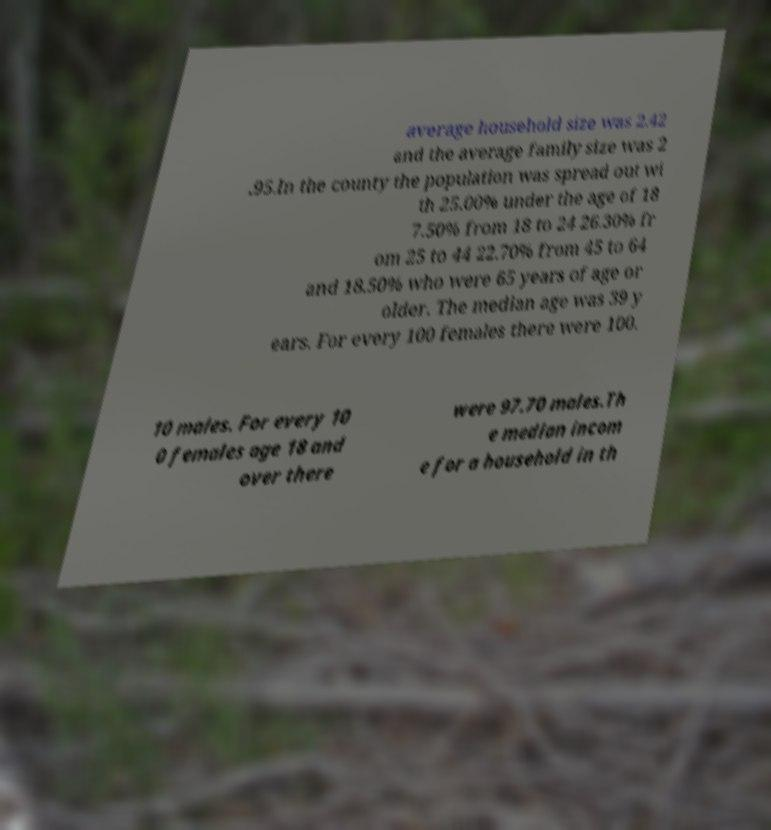Please read and relay the text visible in this image. What does it say? average household size was 2.42 and the average family size was 2 .95.In the county the population was spread out wi th 25.00% under the age of 18 7.50% from 18 to 24 26.30% fr om 25 to 44 22.70% from 45 to 64 and 18.50% who were 65 years of age or older. The median age was 39 y ears. For every 100 females there were 100. 10 males. For every 10 0 females age 18 and over there were 97.70 males.Th e median incom e for a household in th 